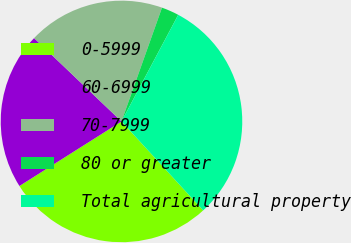Convert chart to OTSL. <chart><loc_0><loc_0><loc_500><loc_500><pie_chart><fcel>0-5999<fcel>60-6999<fcel>70-7999<fcel>80 or greater<fcel>Total agricultural property<nl><fcel>27.84%<fcel>21.1%<fcel>18.32%<fcel>2.34%<fcel>30.4%<nl></chart> 